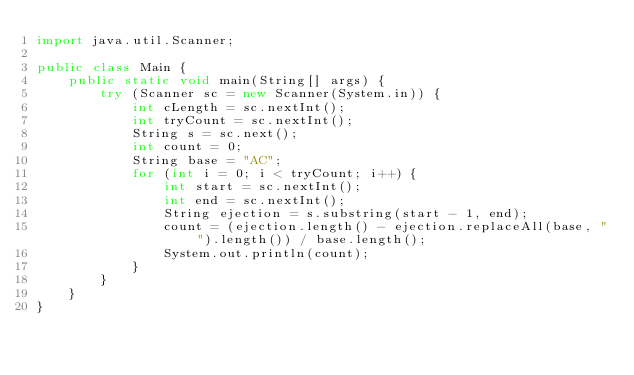Convert code to text. <code><loc_0><loc_0><loc_500><loc_500><_Java_>import java.util.Scanner;

public class Main {
	public static void main(String[] args) {
		try (Scanner sc = new Scanner(System.in)) {
			int cLength = sc.nextInt();
			int tryCount = sc.nextInt();
			String s = sc.next();
			int count = 0;
			String base = "AC";
			for (int i = 0; i < tryCount; i++) {
				int start = sc.nextInt();
				int end = sc.nextInt();
				String ejection = s.substring(start - 1, end);
				count = (ejection.length() - ejection.replaceAll(base, "").length()) / base.length();
			    System.out.println(count);	
			}
		}
	}
}</code> 